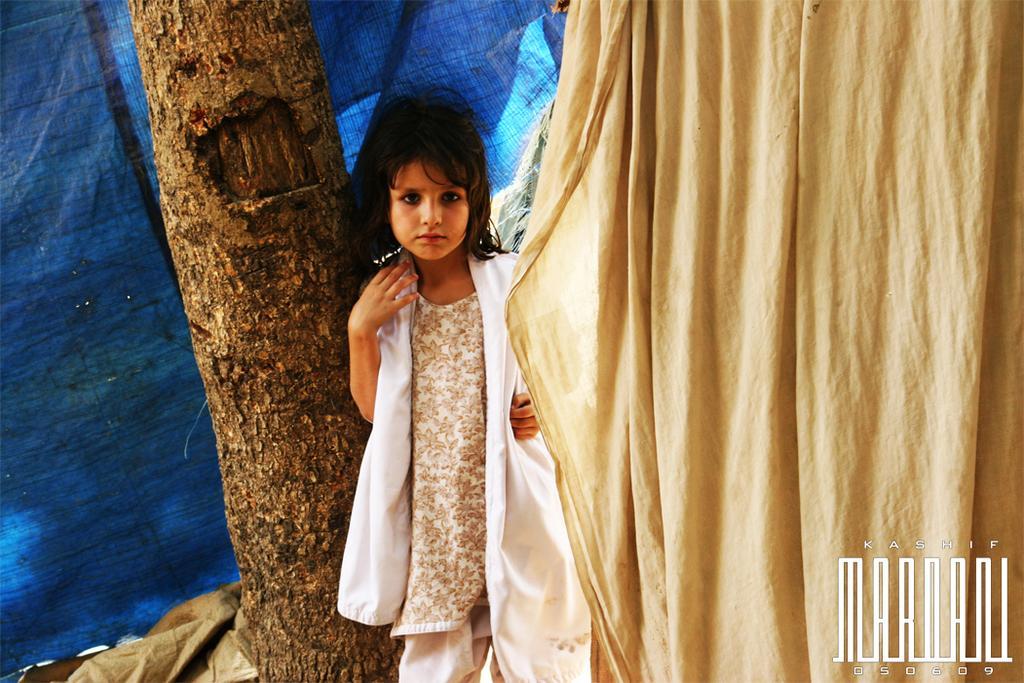Describe this image in one or two sentences. In this image we can see a girl and we can also see the bark of a tree. In the background there is blue color cover and on the right there is cloth. We can also see the text at the bottom. 